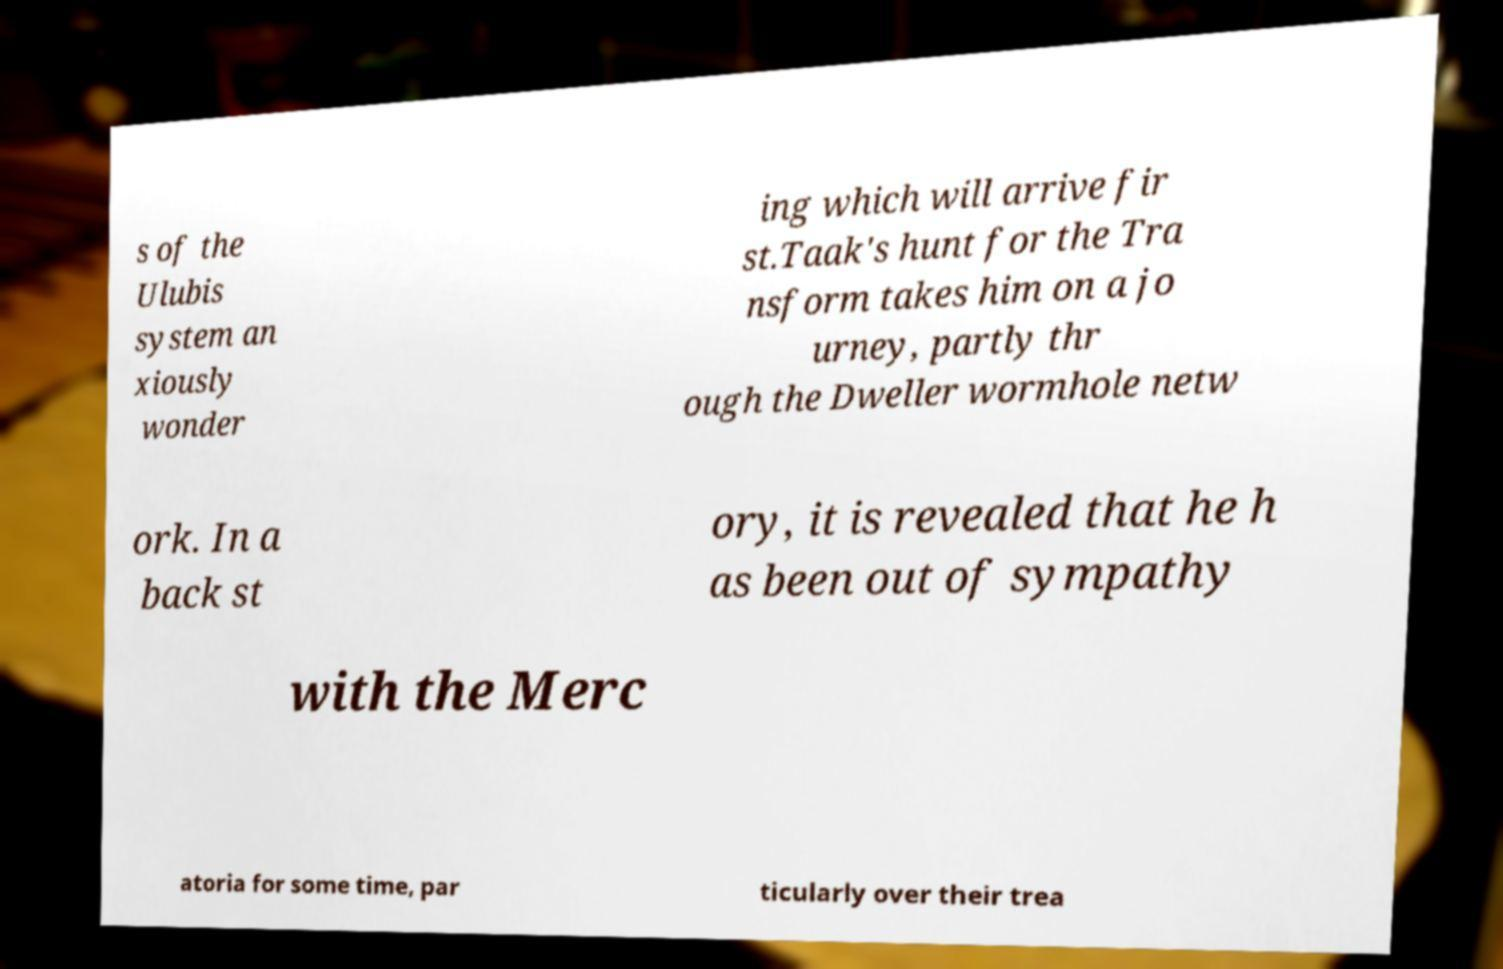Could you assist in decoding the text presented in this image and type it out clearly? s of the Ulubis system an xiously wonder ing which will arrive fir st.Taak's hunt for the Tra nsform takes him on a jo urney, partly thr ough the Dweller wormhole netw ork. In a back st ory, it is revealed that he h as been out of sympathy with the Merc atoria for some time, par ticularly over their trea 